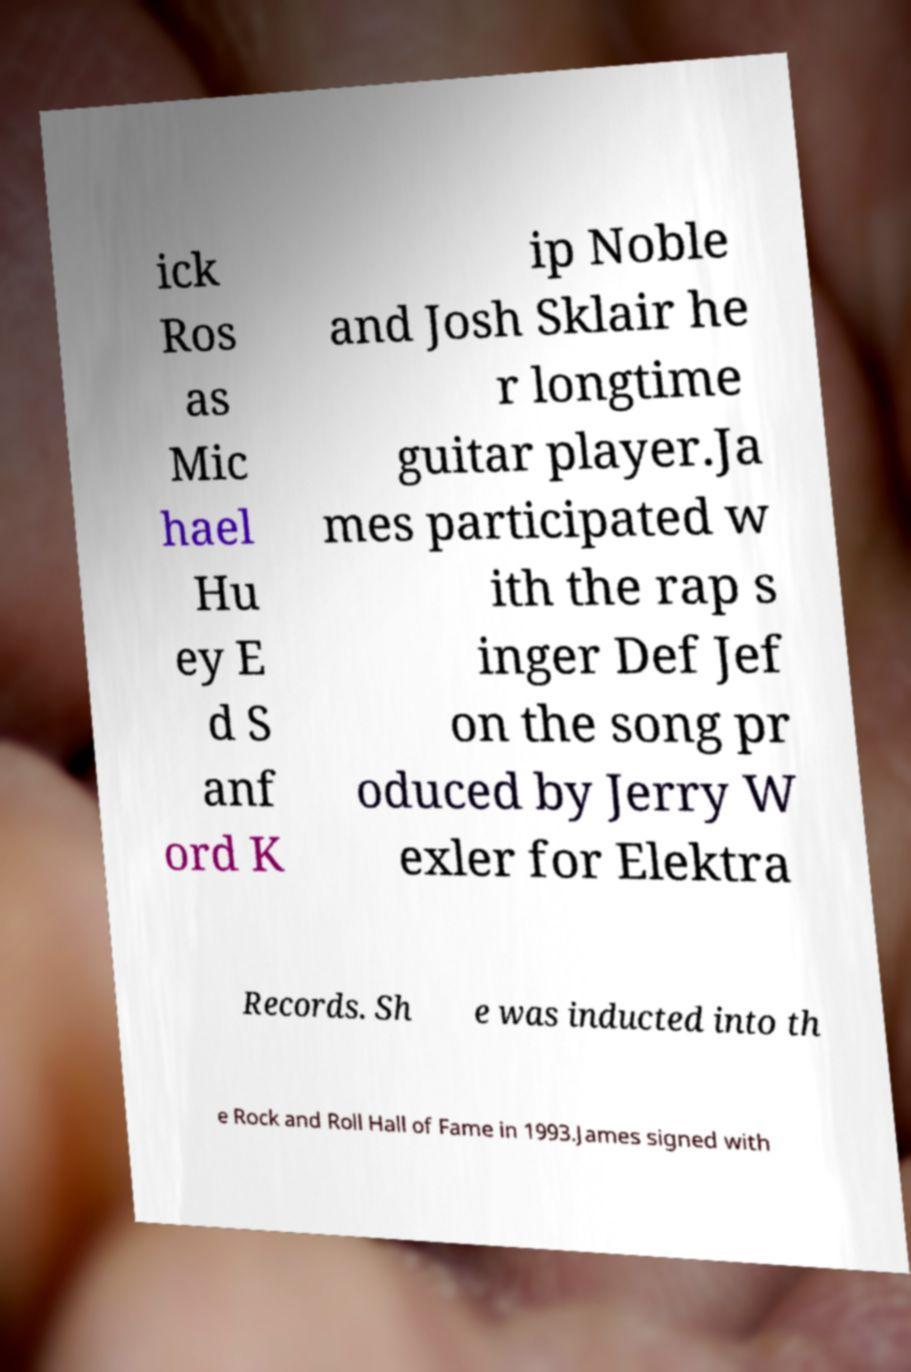Please identify and transcribe the text found in this image. ick Ros as Mic hael Hu ey E d S anf ord K ip Noble and Josh Sklair he r longtime guitar player.Ja mes participated w ith the rap s inger Def Jef on the song pr oduced by Jerry W exler for Elektra Records. Sh e was inducted into th e Rock and Roll Hall of Fame in 1993.James signed with 